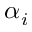<formula> <loc_0><loc_0><loc_500><loc_500>\alpha _ { i }</formula> 